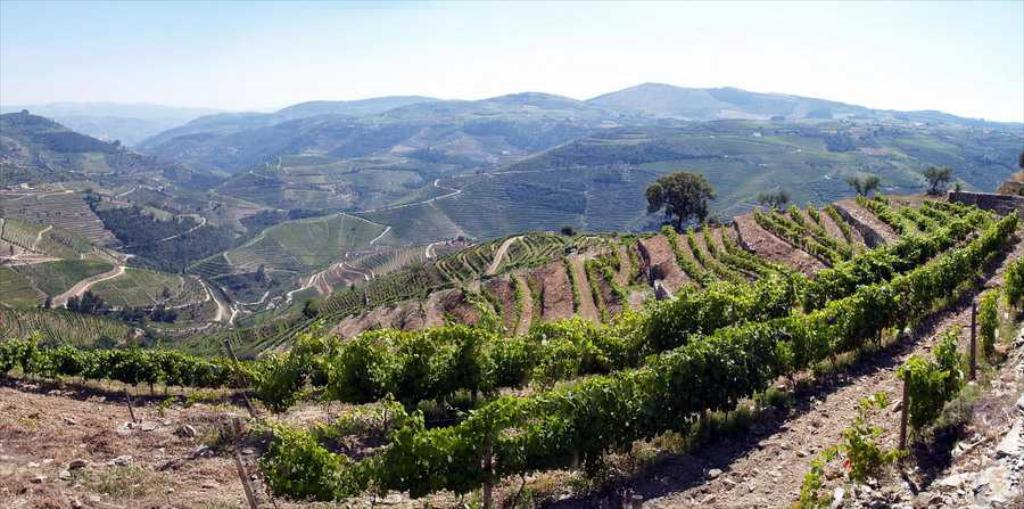What type of natural formation can be seen in the image? There are mountains in the image. What is covering the mountains? The mountains are covered with plants. What specific type of vegetation can be seen on the mountains? Trees are present on the mountains, and grass is visible as well. How many chins can be seen on the trees in the image? There are no chins present in the image, as it features mountains covered with plants and trees. 